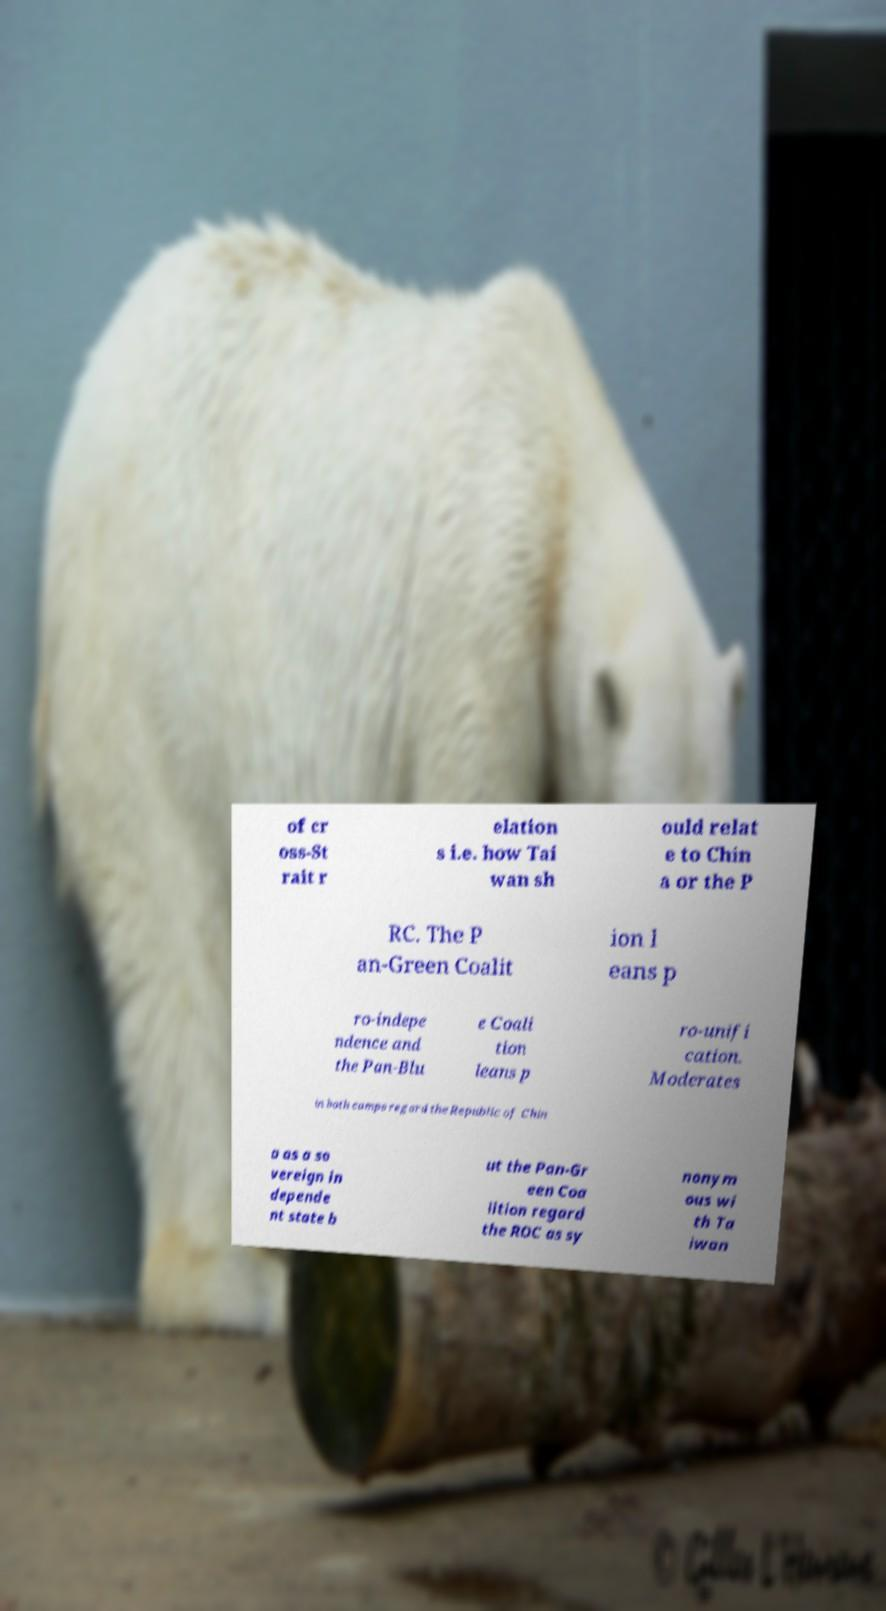Please identify and transcribe the text found in this image. of cr oss-St rait r elation s i.e. how Tai wan sh ould relat e to Chin a or the P RC. The P an-Green Coalit ion l eans p ro-indepe ndence and the Pan-Blu e Coali tion leans p ro-unifi cation. Moderates in both camps regard the Republic of Chin a as a so vereign in depende nt state b ut the Pan-Gr een Coa lition regard the ROC as sy nonym ous wi th Ta iwan 